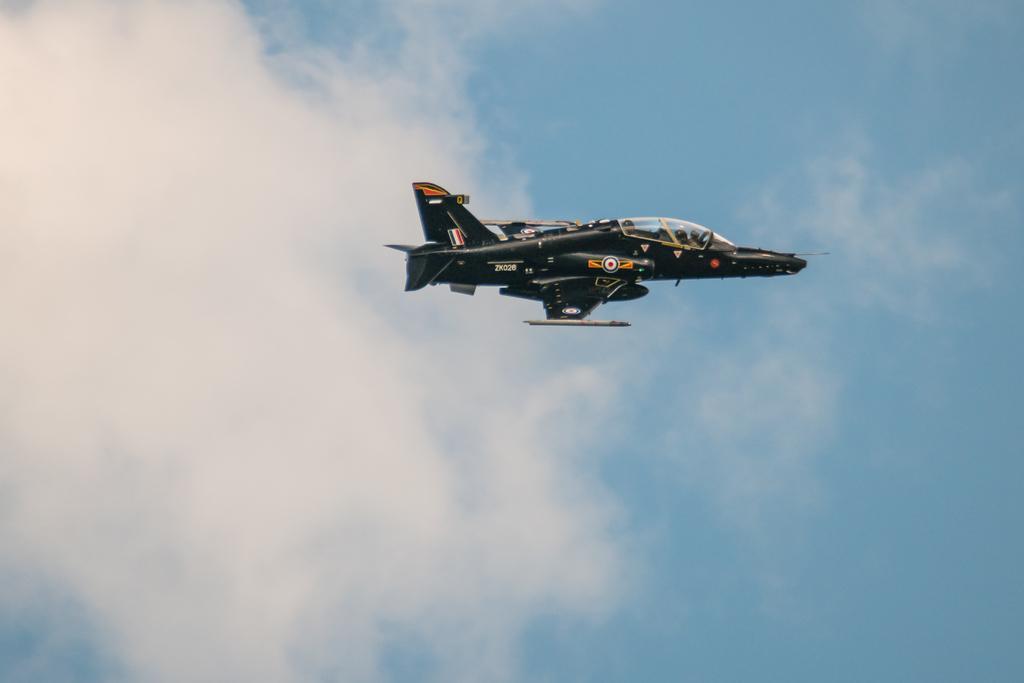Could you give a brief overview of what you see in this image? In this picture we can see an aircraft flying in the air, we can see the sky and clouds in the background. 